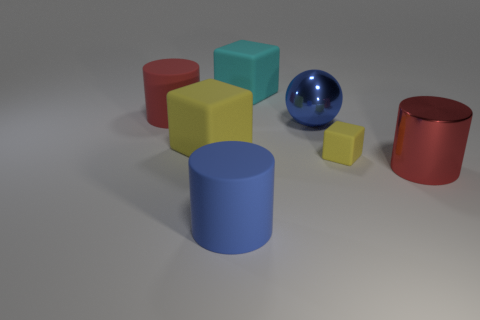Is the number of large cyan rubber blocks greater than the number of yellow rubber cubes?
Offer a terse response. No. Is the large red object on the right side of the big blue ball made of the same material as the big blue cylinder?
Your response must be concise. No. Are there fewer yellow matte things than tiny red things?
Provide a succinct answer. No. There is a yellow rubber thing that is on the left side of the rubber cylinder that is in front of the blue metal sphere; are there any big yellow things to the right of it?
Offer a very short reply. No. Is the shape of the large shiny thing to the right of the small yellow cube the same as  the blue rubber thing?
Offer a terse response. Yes. Is the number of small yellow matte cubes left of the blue shiny sphere greater than the number of big red cylinders?
Make the answer very short. No. Is the color of the matte cylinder that is left of the large blue rubber object the same as the metal cylinder?
Make the answer very short. Yes. What is the color of the matte cylinder in front of the red cylinder that is right of the large blue thing behind the small matte thing?
Make the answer very short. Blue. Do the red rubber thing and the red metal cylinder have the same size?
Keep it short and to the point. Yes. How many metal blocks have the same size as the red matte thing?
Ensure brevity in your answer.  0. 